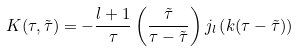<formula> <loc_0><loc_0><loc_500><loc_500>K ( \tau , \tilde { \tau } ) = - \frac { l + 1 } { \tau } \left ( \frac { \tilde { \tau } } { \tau - \tilde { \tau } } \right ) j _ { l } \left ( k ( \tau - \tilde { \tau } ) \right )</formula> 